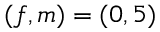Convert formula to latex. <formula><loc_0><loc_0><loc_500><loc_500>( f , m ) = ( 0 , 5 )</formula> 